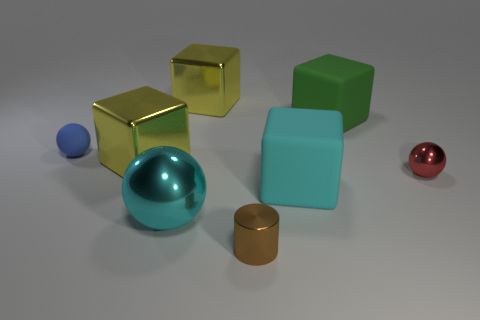There is a object that is the same color as the large metallic ball; what material is it?
Ensure brevity in your answer.  Rubber. What number of other objects are the same color as the large ball?
Ensure brevity in your answer.  1. There is a tiny brown thing; is its shape the same as the big rubber object that is behind the small red thing?
Give a very brief answer. No. Are there fewer green blocks that are in front of the red metallic ball than small blue rubber spheres that are right of the cyan matte block?
Provide a succinct answer. No. What material is the blue object that is the same shape as the red metallic object?
Offer a very short reply. Rubber. Is there anything else that has the same material as the cylinder?
Ensure brevity in your answer.  Yes. Is the large sphere the same color as the small metal cylinder?
Make the answer very short. No. What shape is the green thing that is made of the same material as the blue object?
Keep it short and to the point. Cube. How many tiny red shiny objects have the same shape as the small matte object?
Your answer should be compact. 1. There is a small metallic object that is to the left of the cyan rubber object that is on the right side of the small blue object; what shape is it?
Make the answer very short. Cylinder. 